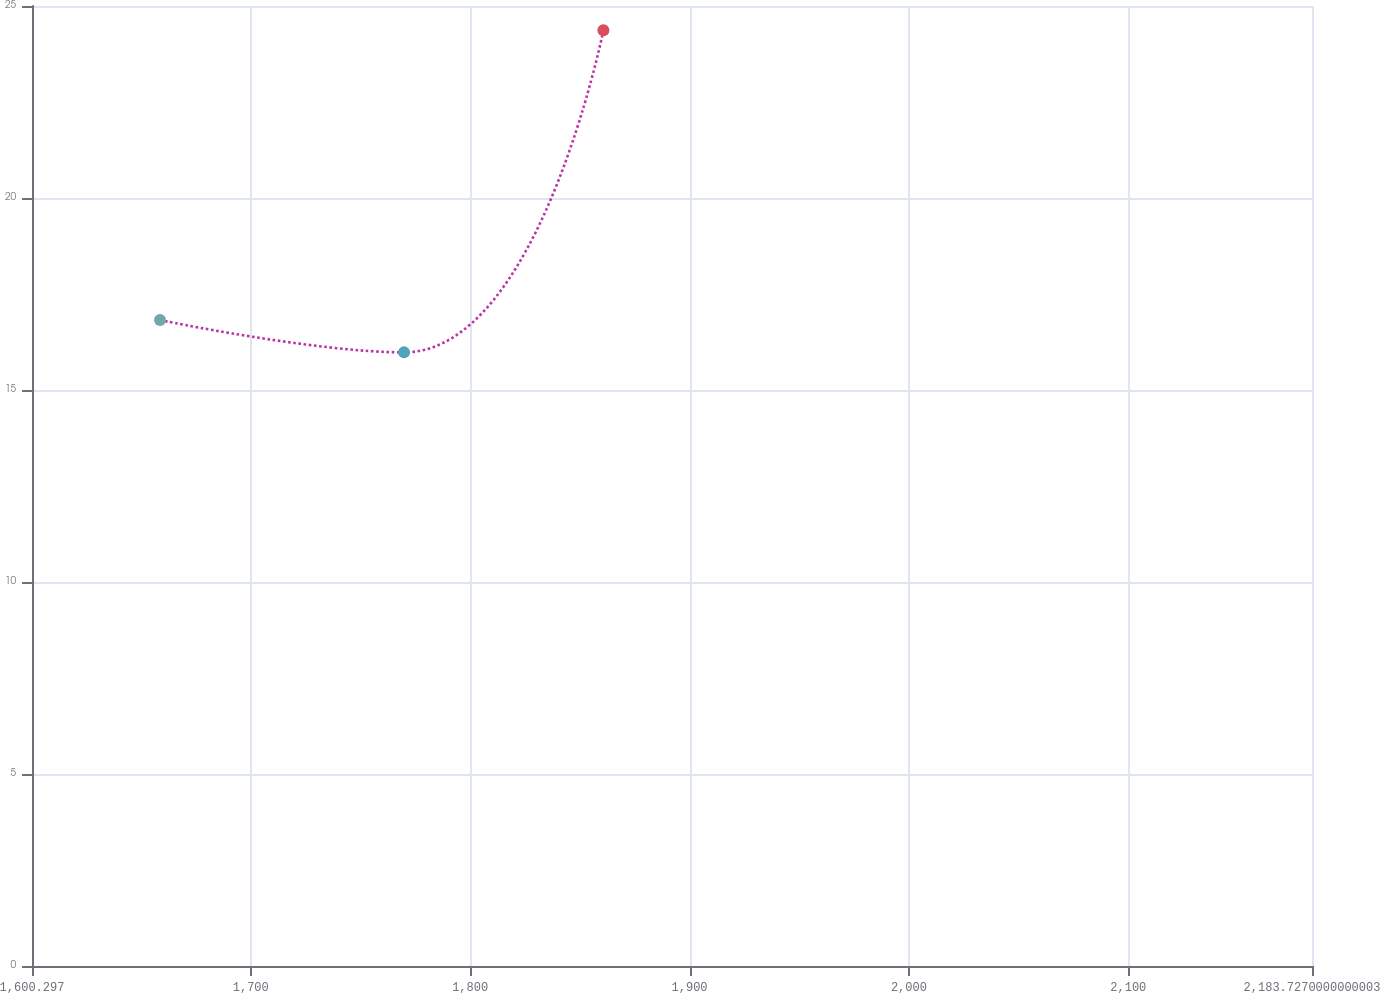Convert chart to OTSL. <chart><loc_0><loc_0><loc_500><loc_500><line_chart><ecel><fcel>Unnamed: 1<nl><fcel>1658.64<fcel>16.82<nl><fcel>1769.87<fcel>15.98<nl><fcel>1860.75<fcel>24.37<nl><fcel>2242.07<fcel>18.06<nl></chart> 